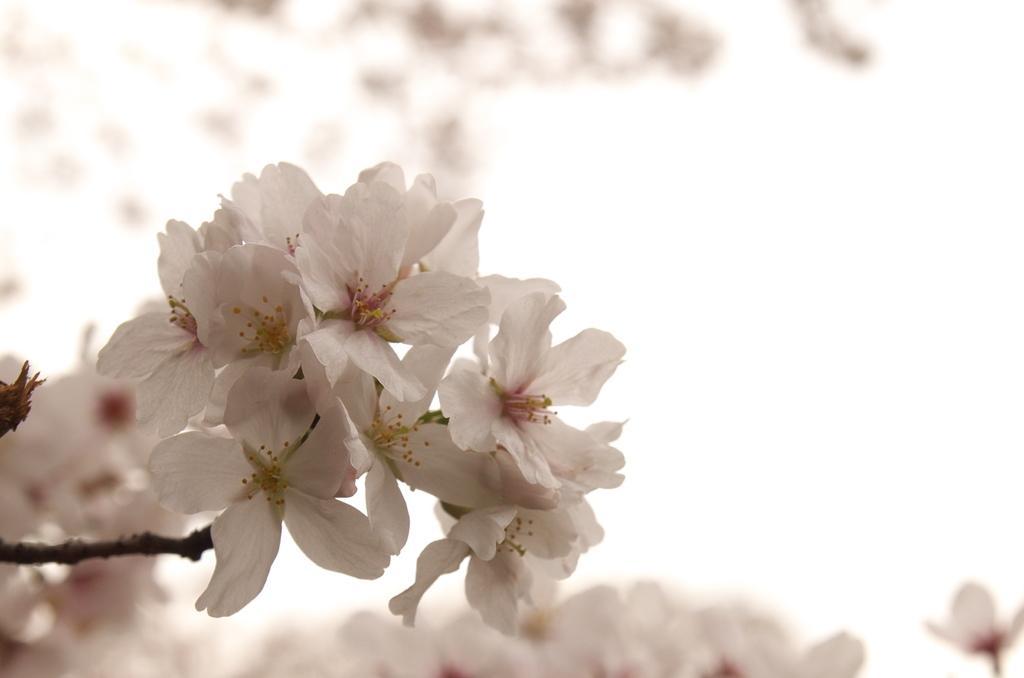Please provide a concise description of this image. In this image we can see many flowers to a plant. There is a blur background in the image. 